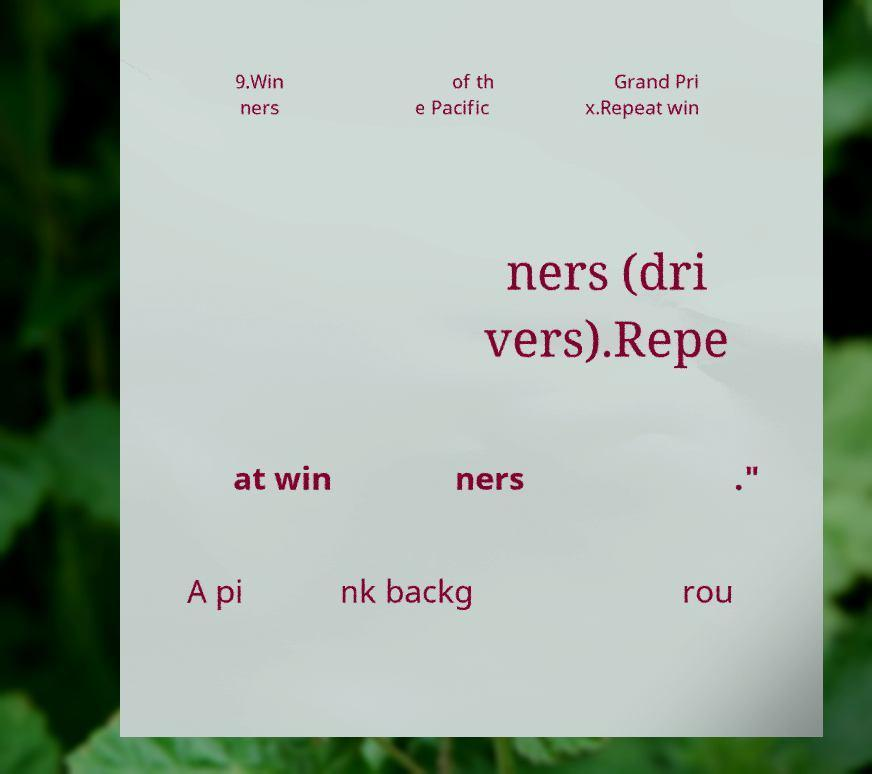For documentation purposes, I need the text within this image transcribed. Could you provide that? 9.Win ners of th e Pacific Grand Pri x.Repeat win ners (dri vers).Repe at win ners ." A pi nk backg rou 